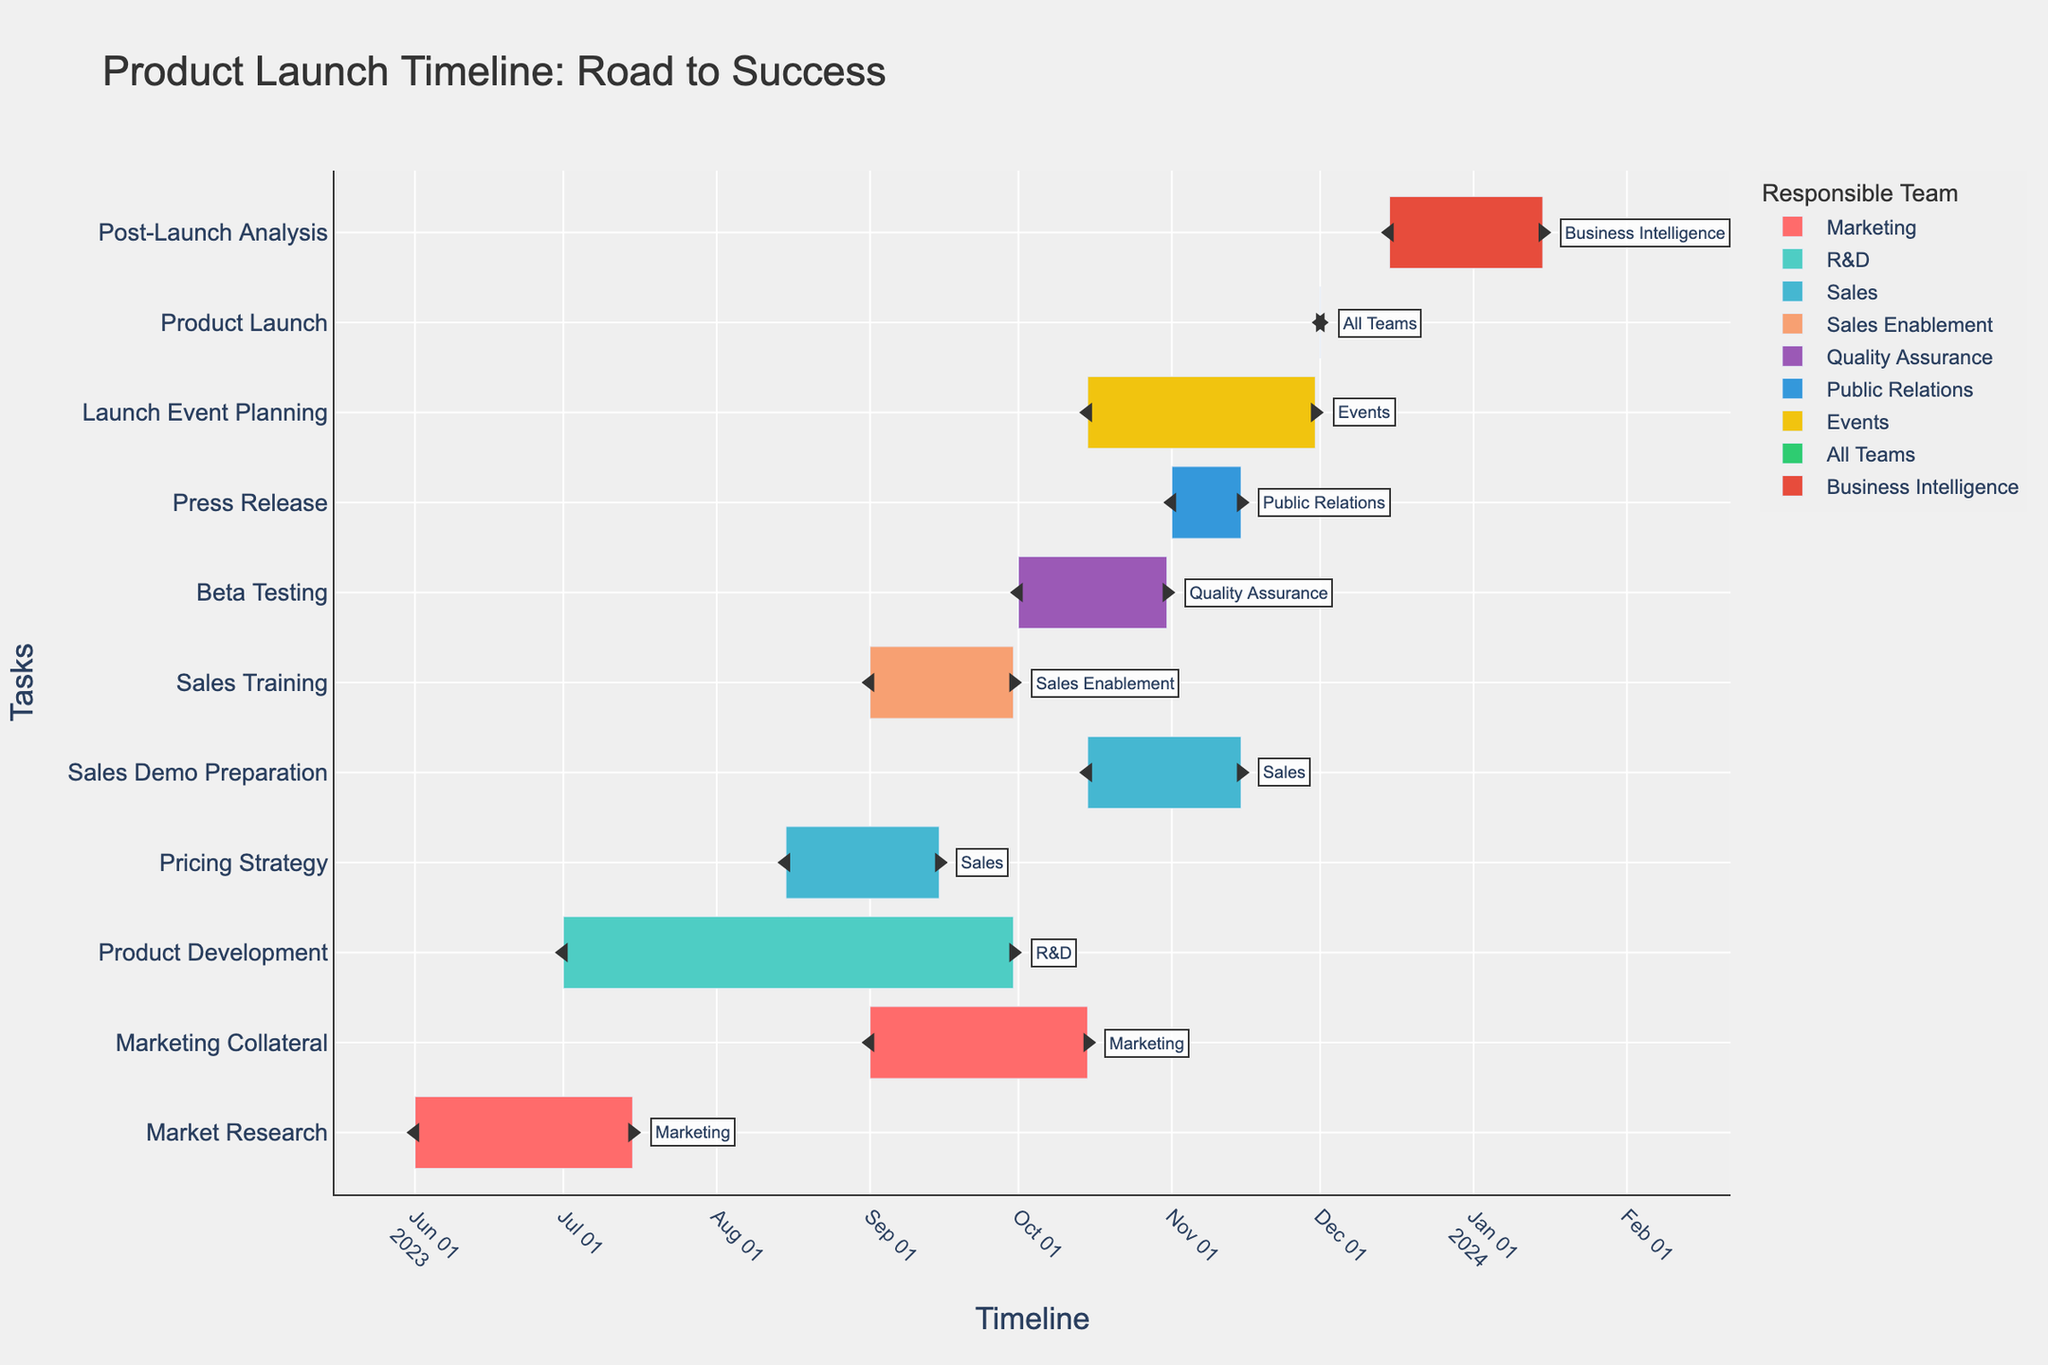What is the title of the plot? The title is displayed at the top of the plot. It describes the contents and purpose of the Gantt chart.
Answer: Product Launch Timeline: Road to Success Which team is responsible for the longest task? To find the longest task, look at the timeline and measure the duration between the start and end dates for each task.
Answer: R&D How many unique teams are responsible for tasks? Each task is color-coded and annotated with the responsible team. Count the distinct team names.
Answer: 9 Which task spans from June 1st to July 15th? Locate the task bar that starts on June 1st and ends on July 15th. Check the y-axis label for its name.
Answer: Market Research During which month does the most overlap of tasks occur? Observe the timeline and identify the month where the maximum number of tasks coincide.
Answer: October What is the total duration of the Sales Demo Preparation task? Look at the start and end dates for Sales Demo Preparation and find the number of days between them.
Answer: 31 days Are there any tasks that end on the same date as another begins? If so, which ones? Check the timeline for tasks that have the same end and start dates. One task should end on the same date another starts for them to transition directly.
Answer: Sales Training ends on Sept 30 and Pricing Strategy ends on Sept 15 while Marketing Collateral spans entirely over both Which team is responsible for the final milestone task, Product Launch? Identify the team responsible for the 'Product Launch' task by looking at the annotation or color.
Answer: All Teams Which tasks involve both Sales and Marketing teams? Identify tasks annotated with Sales or Marketing and those spanning between both team task timelines.
Answer: Sales Demo Preparation (Sales) and Marketing Collateral (Marketing) List all tasks that the Sales team is responsible for. Find all tasks annotated with 'Sales' and list them.
Answer: Pricing Strategy, Sales Demo Preparation 